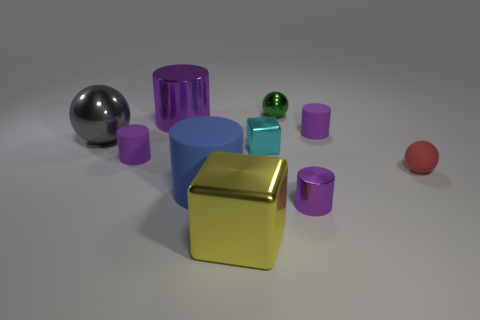What number of tiny green metallic things are there? There is one small green metallic sphere in the image, set against a backdrop of various other geometric shapes and objects, which adds a vivid splash of color to the scene. 